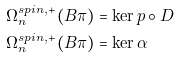Convert formula to latex. <formula><loc_0><loc_0><loc_500><loc_500>\Omega _ { n } ^ { s p i n , + } ( B \pi ) & = \ker p \circ D \\ \Omega _ { n } ^ { s p i n , + } ( B \pi ) & = \ker \alpha</formula> 